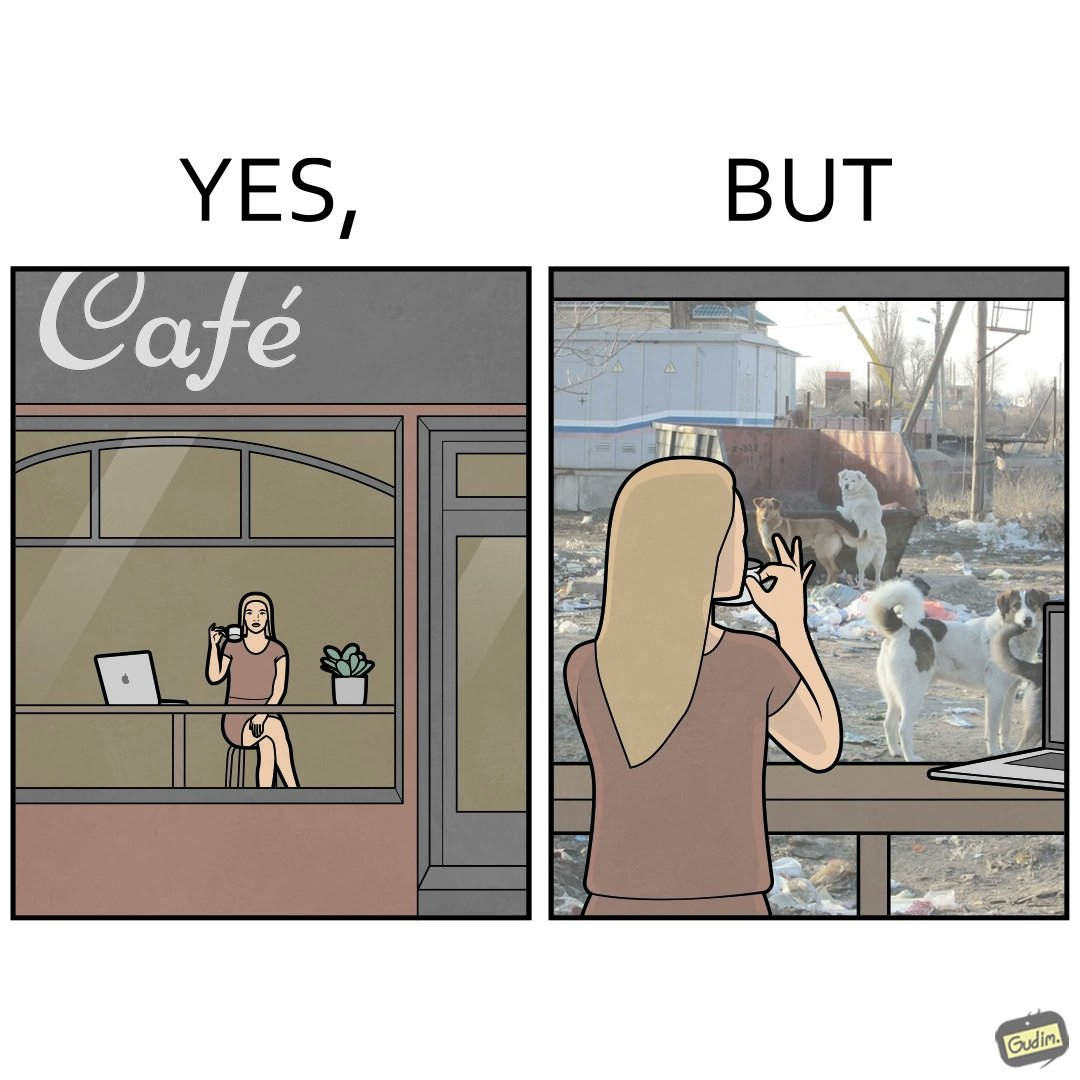Compare the left and right sides of this image. In the left part of the image: a woman having a cup of some hot beverage at some cafe with probably doing some work in the laptop In the right part of the image: a woman looking outside the window at the stray animals, who are probably in search of some food near the garbage bin 